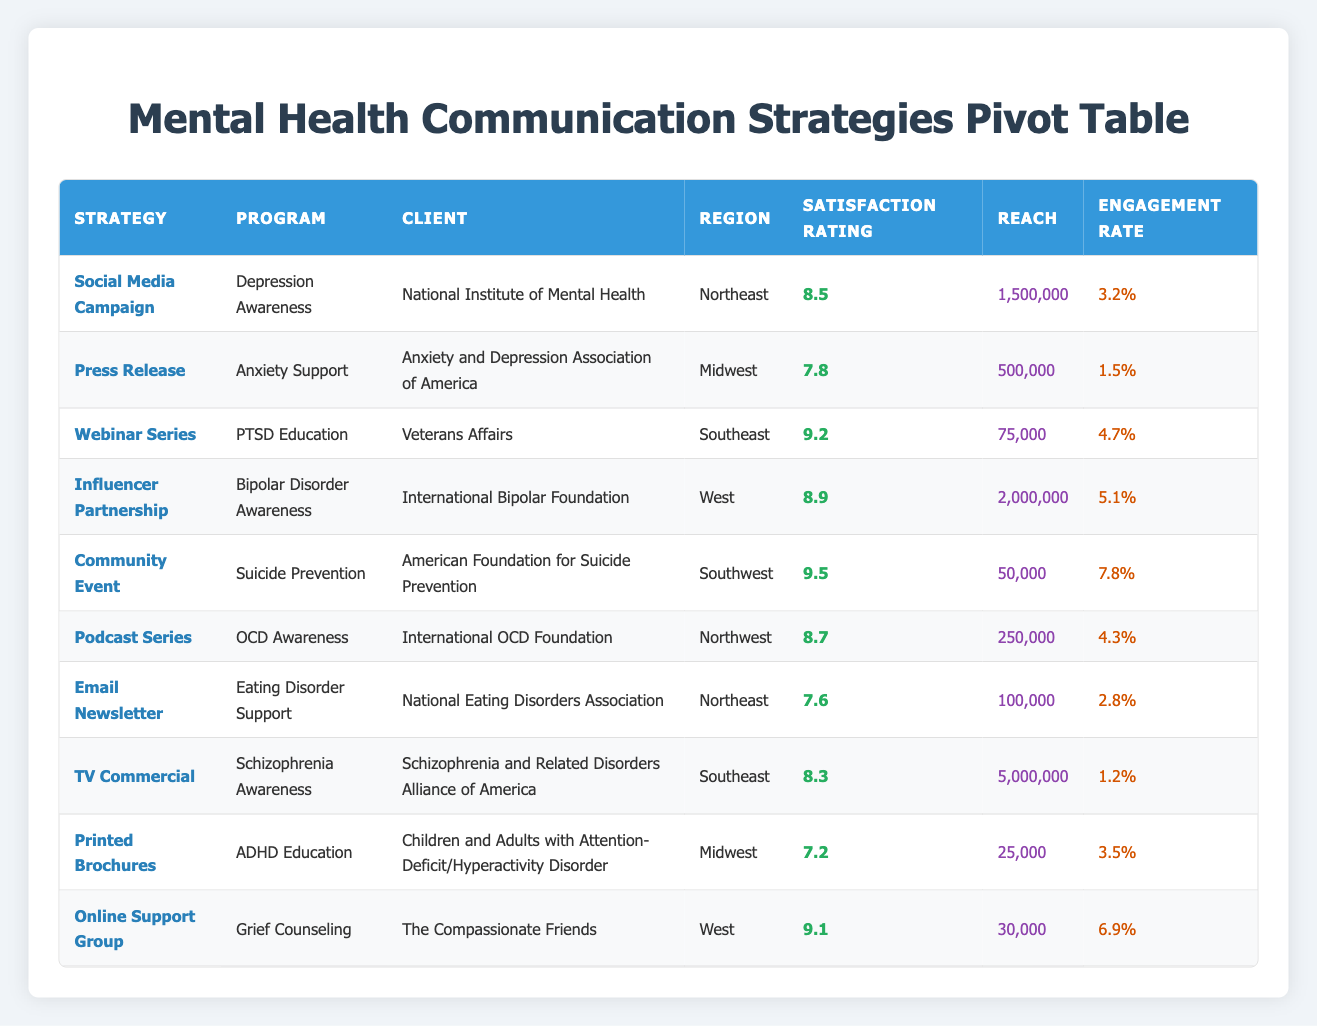What is the Satisfaction Rating for the "Webinar Series" strategy? The table shows that the "Webinar Series" strategy has a "Satisfaction Rating" of 9.2.
Answer: 9.2 Which region has the Client with the highest Satisfaction Rating? The highest Satisfaction Rating in the table is 9.5, which is for the "Community Event" strategy located in the "Southwest".
Answer: Southwest What is the total Reach of all strategies combined? Adding the Reach values for all strategies: 1,500,000 + 500,000 + 75,000 + 2,000,000 + 50,000 + 250,000 + 100,000 + 5,000,000 + 25,000 + 30,000 equals a total of 9,530,000.
Answer: 9,530,000 Is there a strategy with an Engagement Rate higher than 5%? The "Community Event" has an Engagement Rate of 7.8%, which is higher than 5%, confirming that there is indeed a strategy above that threshold.
Answer: Yes What is the average Satisfaction Rating for all strategies listed in the table? To find the average, sum all the Satisfaction Ratings: (8.5 + 7.8 + 9.2 + 8.9 + 9.5 + 8.7 + 7.6 + 8.3 + 7.2 + 9.1) = 88.8, then divide by the number of strategies (10), resulting in an average of 8.88.
Answer: 8.88 Which communication strategy had the least Reach, and what was its Satisfaction Rating? The "Printed Brochures" strategy had the least Reach at 25,000, along with a Satisfaction Rating of 7.2.
Answer: Printed Brochures, 7.2 How many clients from the Midwest region have a Satisfaction Rating above 7.5? In the Midwest, there are two clients: "Press Release" with a 7.8 rating and "Printed Brochures" with a 7.2 rating. Only the "Press Release" exceeds 7.5, making the count one.
Answer: 1 What is the difference in Satisfaction Rating between the highest and lowest rated strategies? The highest Satisfaction Rating (9.5 from "Community Event") minus the lowest (7.2 from "Printed Brochures") gives us a difference of 2.3.
Answer: 2.3 Which strategy had the highest Engagement Rate, and what was that rate? The "Community Event" strategy had the highest Engagement Rate at 7.8%.
Answer: Community Event, 7.8% 